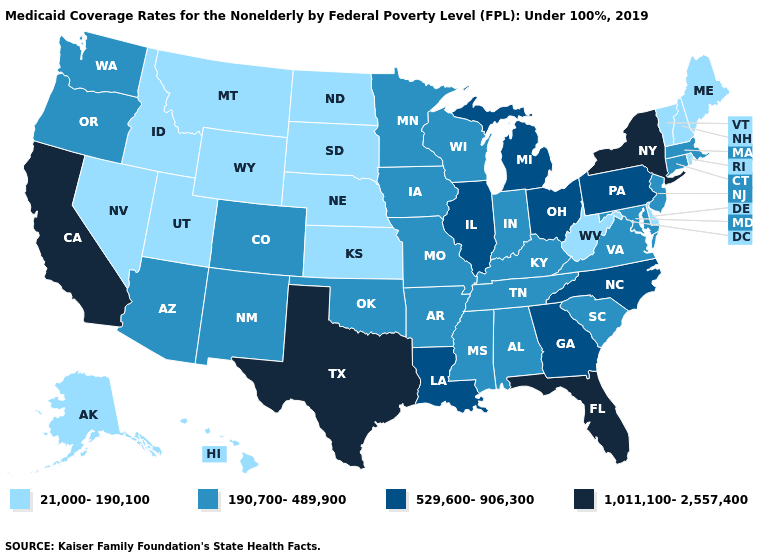Among the states that border New Jersey , which have the highest value?
Give a very brief answer. New York. Name the states that have a value in the range 529,600-906,300?
Short answer required. Georgia, Illinois, Louisiana, Michigan, North Carolina, Ohio, Pennsylvania. Which states have the highest value in the USA?
Give a very brief answer. California, Florida, New York, Texas. Name the states that have a value in the range 190,700-489,900?
Write a very short answer. Alabama, Arizona, Arkansas, Colorado, Connecticut, Indiana, Iowa, Kentucky, Maryland, Massachusetts, Minnesota, Mississippi, Missouri, New Jersey, New Mexico, Oklahoma, Oregon, South Carolina, Tennessee, Virginia, Washington, Wisconsin. Which states hav the highest value in the MidWest?
Write a very short answer. Illinois, Michigan, Ohio. Among the states that border Ohio , does Pennsylvania have the highest value?
Answer briefly. Yes. What is the value of Connecticut?
Give a very brief answer. 190,700-489,900. Which states have the lowest value in the West?
Answer briefly. Alaska, Hawaii, Idaho, Montana, Nevada, Utah, Wyoming. Which states hav the highest value in the Northeast?
Concise answer only. New York. Among the states that border North Carolina , which have the lowest value?
Short answer required. South Carolina, Tennessee, Virginia. What is the highest value in the West ?
Quick response, please. 1,011,100-2,557,400. Does Massachusetts have the same value as Wisconsin?
Keep it brief. Yes. Does New Hampshire have the lowest value in the Northeast?
Write a very short answer. Yes. Does the first symbol in the legend represent the smallest category?
Be succinct. Yes. What is the value of Ohio?
Answer briefly. 529,600-906,300. 